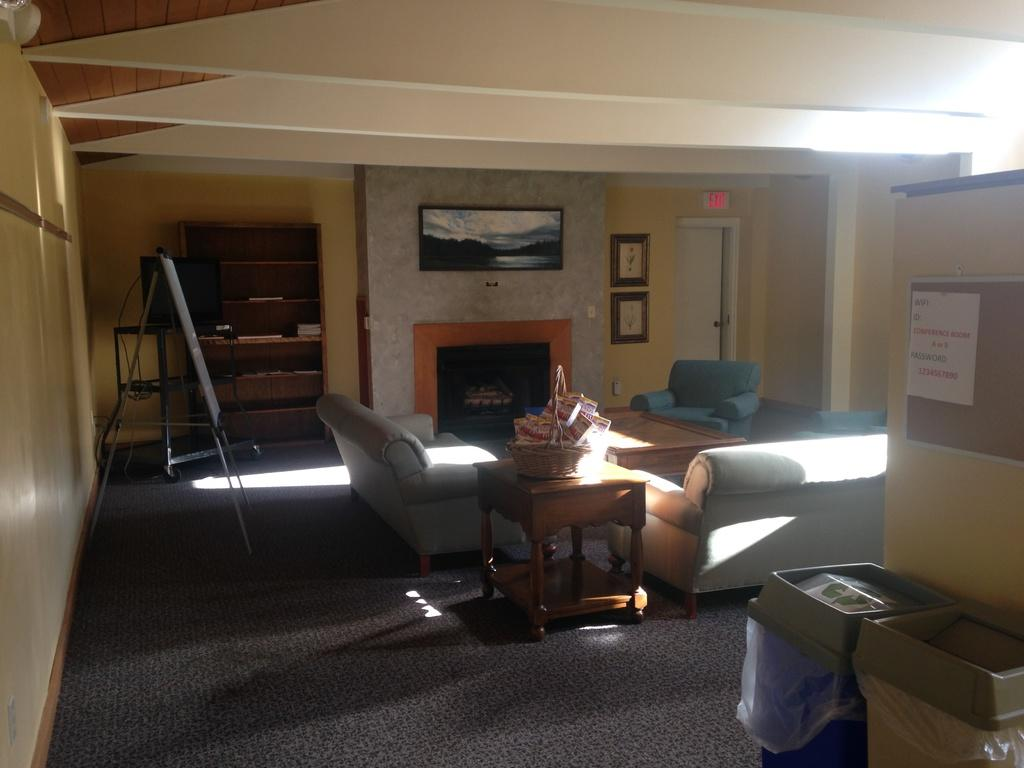What type of space is depicted in the image? There is a room in the image. What furniture can be seen in the room? There are sofas and a table in the room. What items are placed on the table? There is a basket on the table. What is the purpose of the board with a stand in the room? The purpose of the board with a stand is not specified in the image. How can one enter or exit the room? There is a door in the room for entering or exiting. What type of decorations are on the wall? There are frames on the wall. What type of screen is present in the room? There is a screen in the room, but its purpose is not specified. What type of poster is in the room? There is a poster in the room, but its content is not specified. What type of storage containers are in the room? There are bins in the room for storage. What type of storage furniture is in the room? There is a cupboard in the room for storage. How many nails are used to hang the frames on the wall in the image? The number of nails used to hang the frames on the wall is not specified in the image. What is the fifth item on the list of items in the room? The provided facts do not list items in a specific order, so there is no "fifth" item. What is the size of the cent in the room? There is no mention of a cent in the image. 